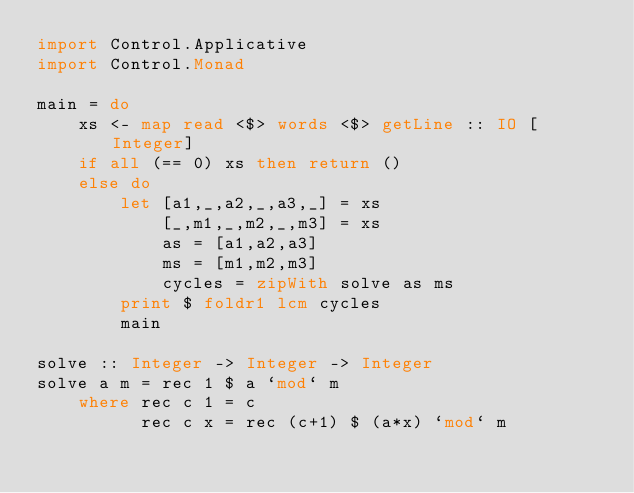<code> <loc_0><loc_0><loc_500><loc_500><_Haskell_>import Control.Applicative
import Control.Monad

main = do
    xs <- map read <$> words <$> getLine :: IO [Integer]
    if all (== 0) xs then return ()
    else do
        let [a1,_,a2,_,a3,_] = xs
            [_,m1,_,m2,_,m3] = xs
            as = [a1,a2,a3]
            ms = [m1,m2,m3]
            cycles = zipWith solve as ms
        print $ foldr1 lcm cycles
        main

solve :: Integer -> Integer -> Integer
solve a m = rec 1 $ a `mod` m
    where rec c 1 = c
          rec c x = rec (c+1) $ (a*x) `mod` m</code> 